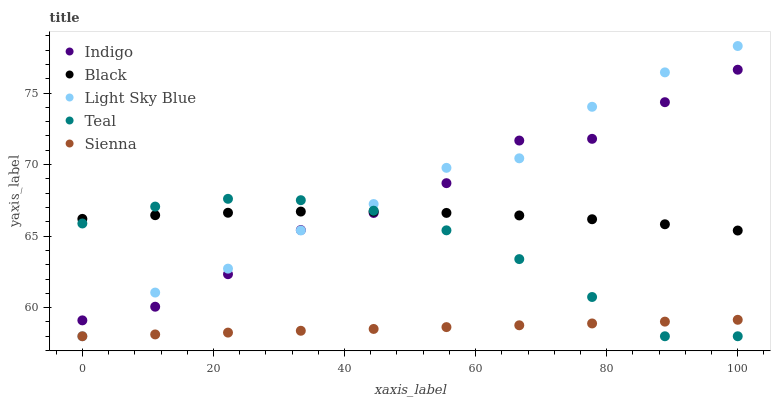Does Sienna have the minimum area under the curve?
Answer yes or no. Yes. Does Light Sky Blue have the maximum area under the curve?
Answer yes or no. Yes. Does Black have the minimum area under the curve?
Answer yes or no. No. Does Black have the maximum area under the curve?
Answer yes or no. No. Is Sienna the smoothest?
Answer yes or no. Yes. Is Indigo the roughest?
Answer yes or no. Yes. Is Black the smoothest?
Answer yes or no. No. Is Black the roughest?
Answer yes or no. No. Does Sienna have the lowest value?
Answer yes or no. Yes. Does Black have the lowest value?
Answer yes or no. No. Does Light Sky Blue have the highest value?
Answer yes or no. Yes. Does Black have the highest value?
Answer yes or no. No. Is Sienna less than Black?
Answer yes or no. Yes. Is Black greater than Sienna?
Answer yes or no. Yes. Does Teal intersect Sienna?
Answer yes or no. Yes. Is Teal less than Sienna?
Answer yes or no. No. Is Teal greater than Sienna?
Answer yes or no. No. Does Sienna intersect Black?
Answer yes or no. No. 